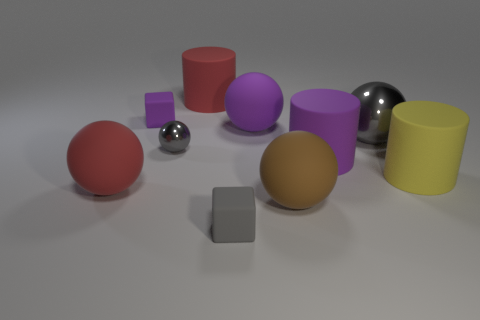Is the color of the small shiny thing the same as the big metal ball?
Keep it short and to the point. Yes. What number of objects are the same size as the red rubber sphere?
Offer a very short reply. 6. Are there fewer small gray shiny spheres that are right of the small ball than purple rubber cylinders that are on the left side of the yellow rubber thing?
Provide a short and direct response. Yes. There is a gray object that is to the right of the tiny gray thing that is right of the matte cylinder that is behind the tiny purple rubber block; what is its size?
Your answer should be very brief. Large. How big is the object that is both right of the gray matte block and in front of the large red matte sphere?
Make the answer very short. Large. There is a large purple matte thing in front of the large sphere right of the large brown ball; what is its shape?
Keep it short and to the point. Cylinder. What is the shape of the small matte thing that is in front of the tiny gray metallic thing?
Offer a very short reply. Cube. What is the shape of the thing that is both behind the big purple ball and in front of the large red cylinder?
Make the answer very short. Cube. How many red objects are either small spheres or matte spheres?
Give a very brief answer. 1. There is a metallic ball that is right of the small metallic ball; is its color the same as the tiny sphere?
Provide a short and direct response. Yes. 